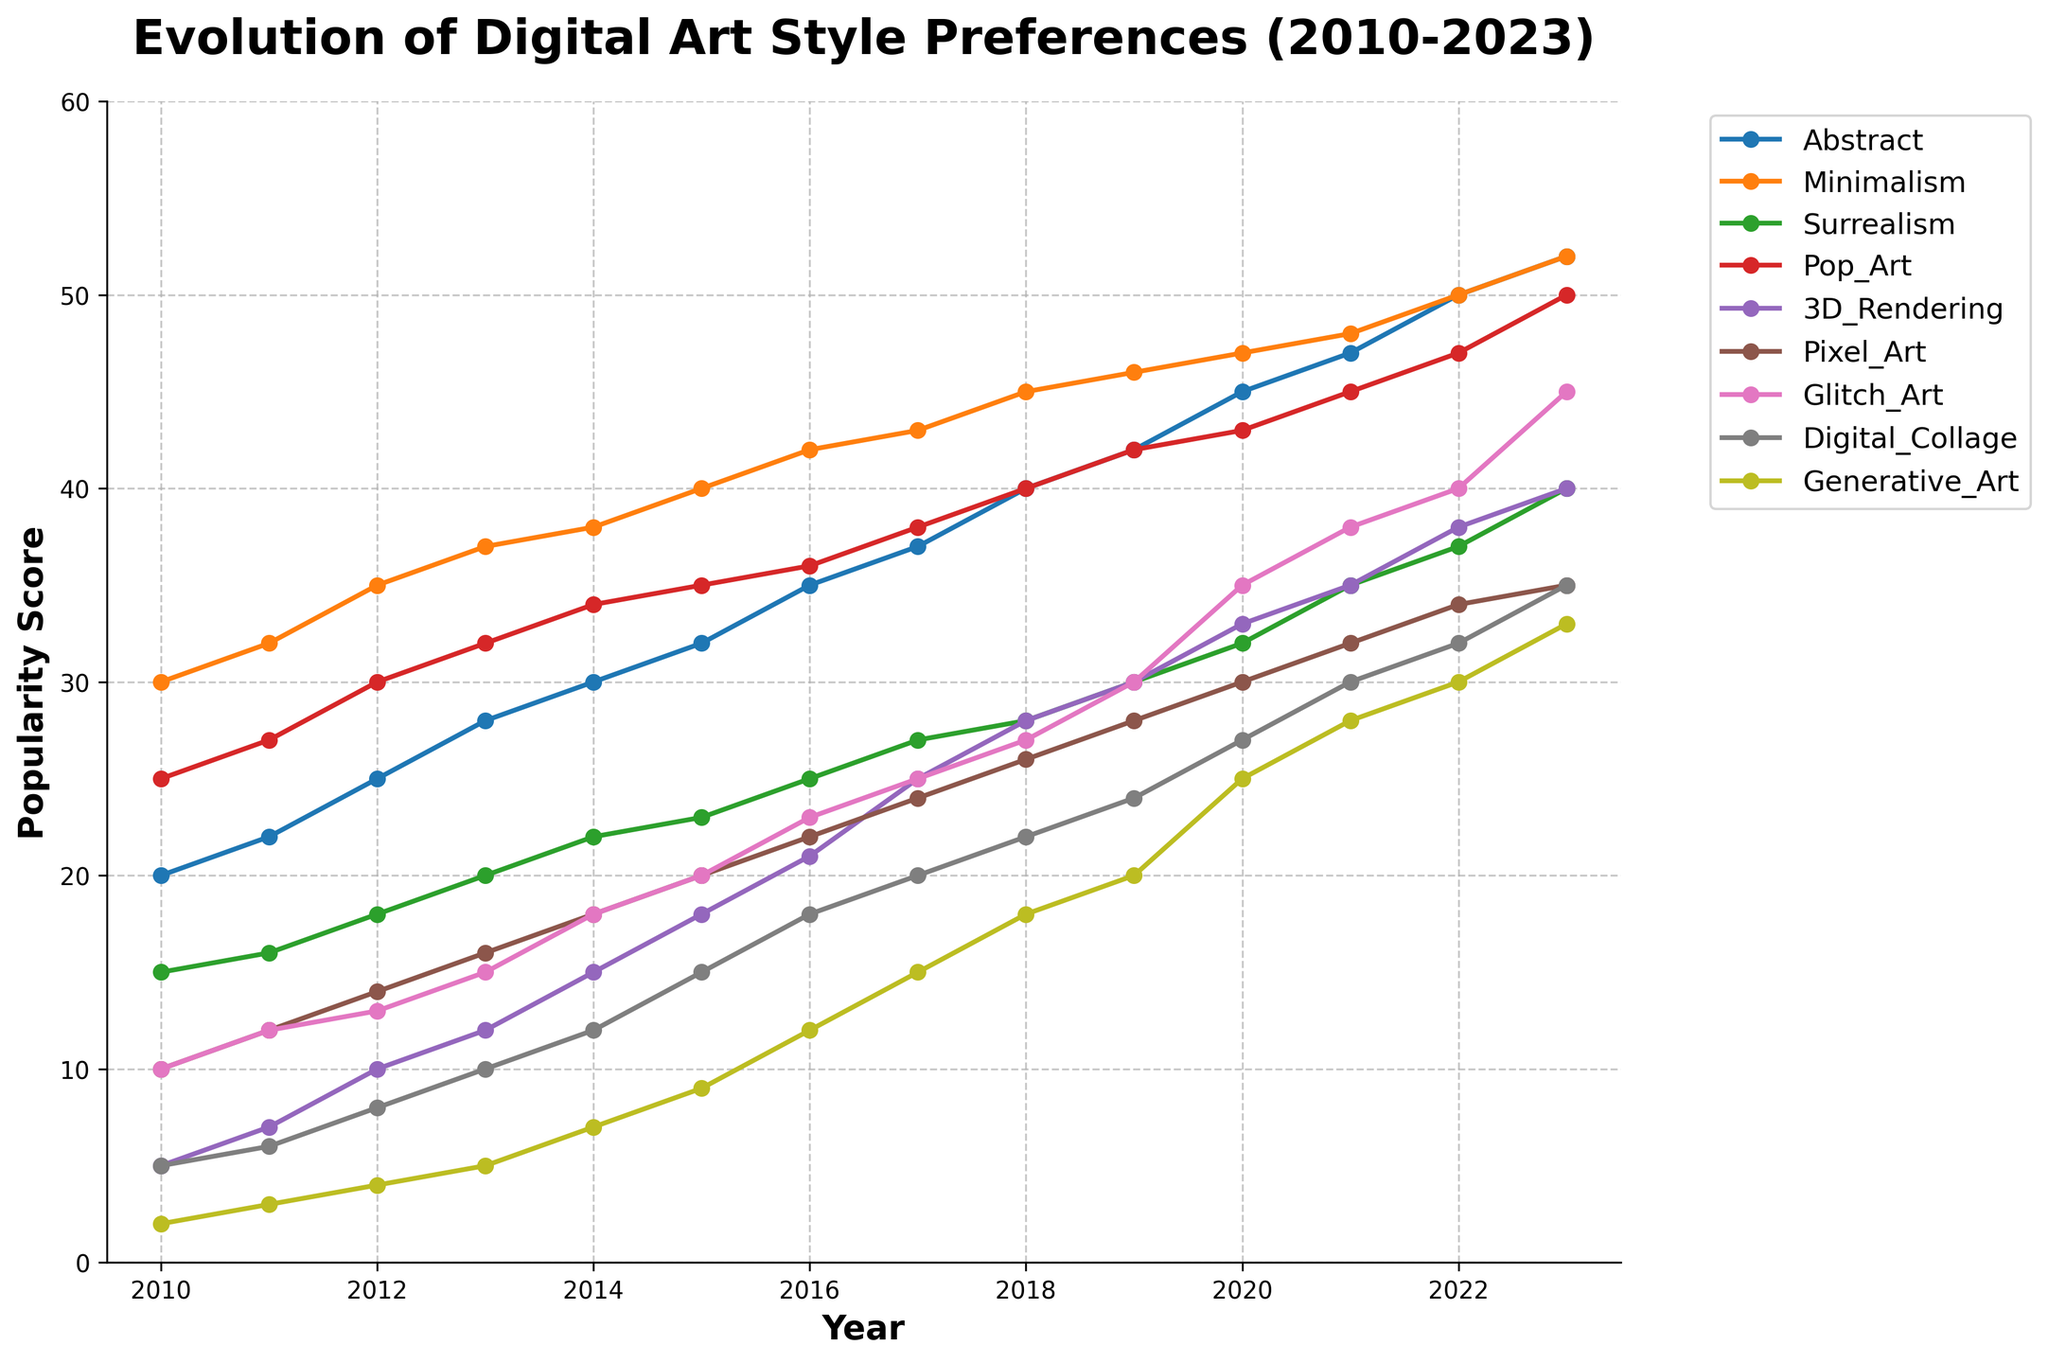What is the title of the figure? The title is centered at the top of the figure. By looking at its position and font size, it can be identified as "Evolution of Digital Art Style Preferences (2010-2023)".
Answer: Evolution of Digital Art Style Preferences (2010-2023) Which digital art style had the highest popularity score in 2023? By looking at the endpoints of the lines for the year 2023, we can see that the style with the highest data point in 2023 is "Minimalism," with a score of 52.
Answer: Minimalism Between which years did Digital Collage show the most significant increase in popularity? To find the most significant increase, look at the slope of the "Digital Collage" line between consecutive years; the steepest section indicates the most significant increase, which is between 2016 and 2017.
Answer: 2016 to 2017 In which year did Generative Art first surpass a popularity score of 20? By following the line for Generative Art and identifying the point when it first goes above the 20-mark on the y-axis, we see this happens in 2019.
Answer: 2019 What was the popularity score difference between Abstract and Pixel Art in 2015? Find the data points for Abstract and Pixel Art in 2015: Abstract has a score of 32 and Pixel Art has a score of 20. The difference is 32 - 20 = 12.
Answer: 12 Which art styles had a popularity score of 50 or more in 2023? By examining the y-values for 2023, we see that "Abstract," "Minimalism," and "Pop Art" all have scores of 50 or above.
Answer: Abstract, Minimalism, Pop Art How did the popularity score of Surrealism change from 2010 to 2023? Look at the Surrealism data points for 2010 and 2023. Surrealism's score in 2010 was 15, and in 2023, it was 40. This is an increase of 40 - 15 = 25.
Answer: Increased by 25 Which digital art style had the highest relative increase in popularity from 2010 to 2023? Calculate the relative increase (percentage) for each style: ((score in 2023 - score in 2010) / score in 2010) * 100. The style with the highest relative increase is "Glitch Art," with a starting score of 10 in 2010 and a score of 45 in 2023, yielding an increase of ((45 - 10) / 10) * 100 = 350%.
Answer: Glitch Art Is there any year where the popularity score of Generative Art did not increase from the previous year? Examine the Generative Art line year by year; it is consistently increasing, showing no year where the score did not increase from the previous year.
Answer: No What is the average popularity score of 3D Rendering from 2010 to 2023? Sum the 3D Rendering scores from 2010 to 2023: (5 + 7 + 10 + 12 + 15 + 18 + 21 + 25 + 28 + 30 + 33 + 35 + 38 + 40) = 317. Divide by the number of years, 14. The average is 317 / 14 ≈ 22.64.
Answer: 22.64 